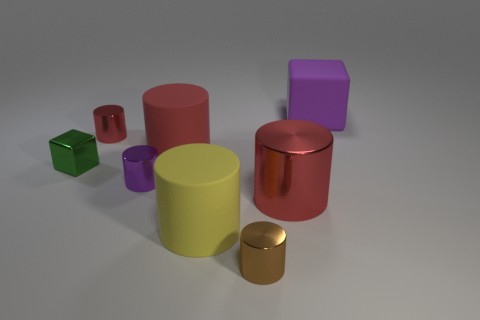Do the objects convey a sense of order or randomness in their placement? The placement of the objects seems rather random, without any discernible pattern. They are spaced out across the surface, with varying distances between them, suggesting no intentional order. 